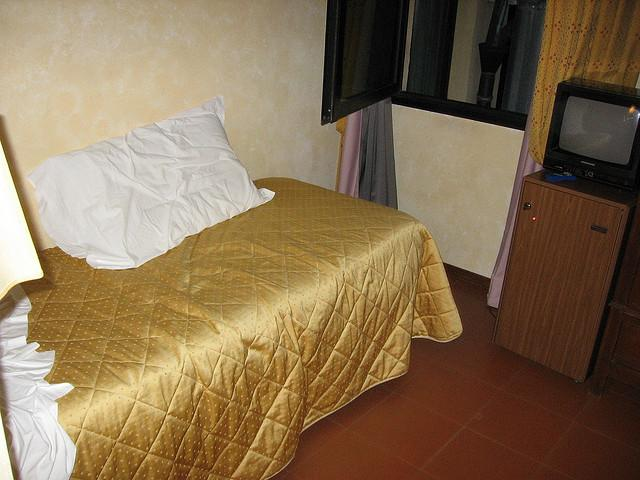What color is the sheet covering the small twin bed on the corner of the room? Please explain your reasoning. yellow. Noe of these options are correct. the sheet is white and the cover is gold and yellow. 